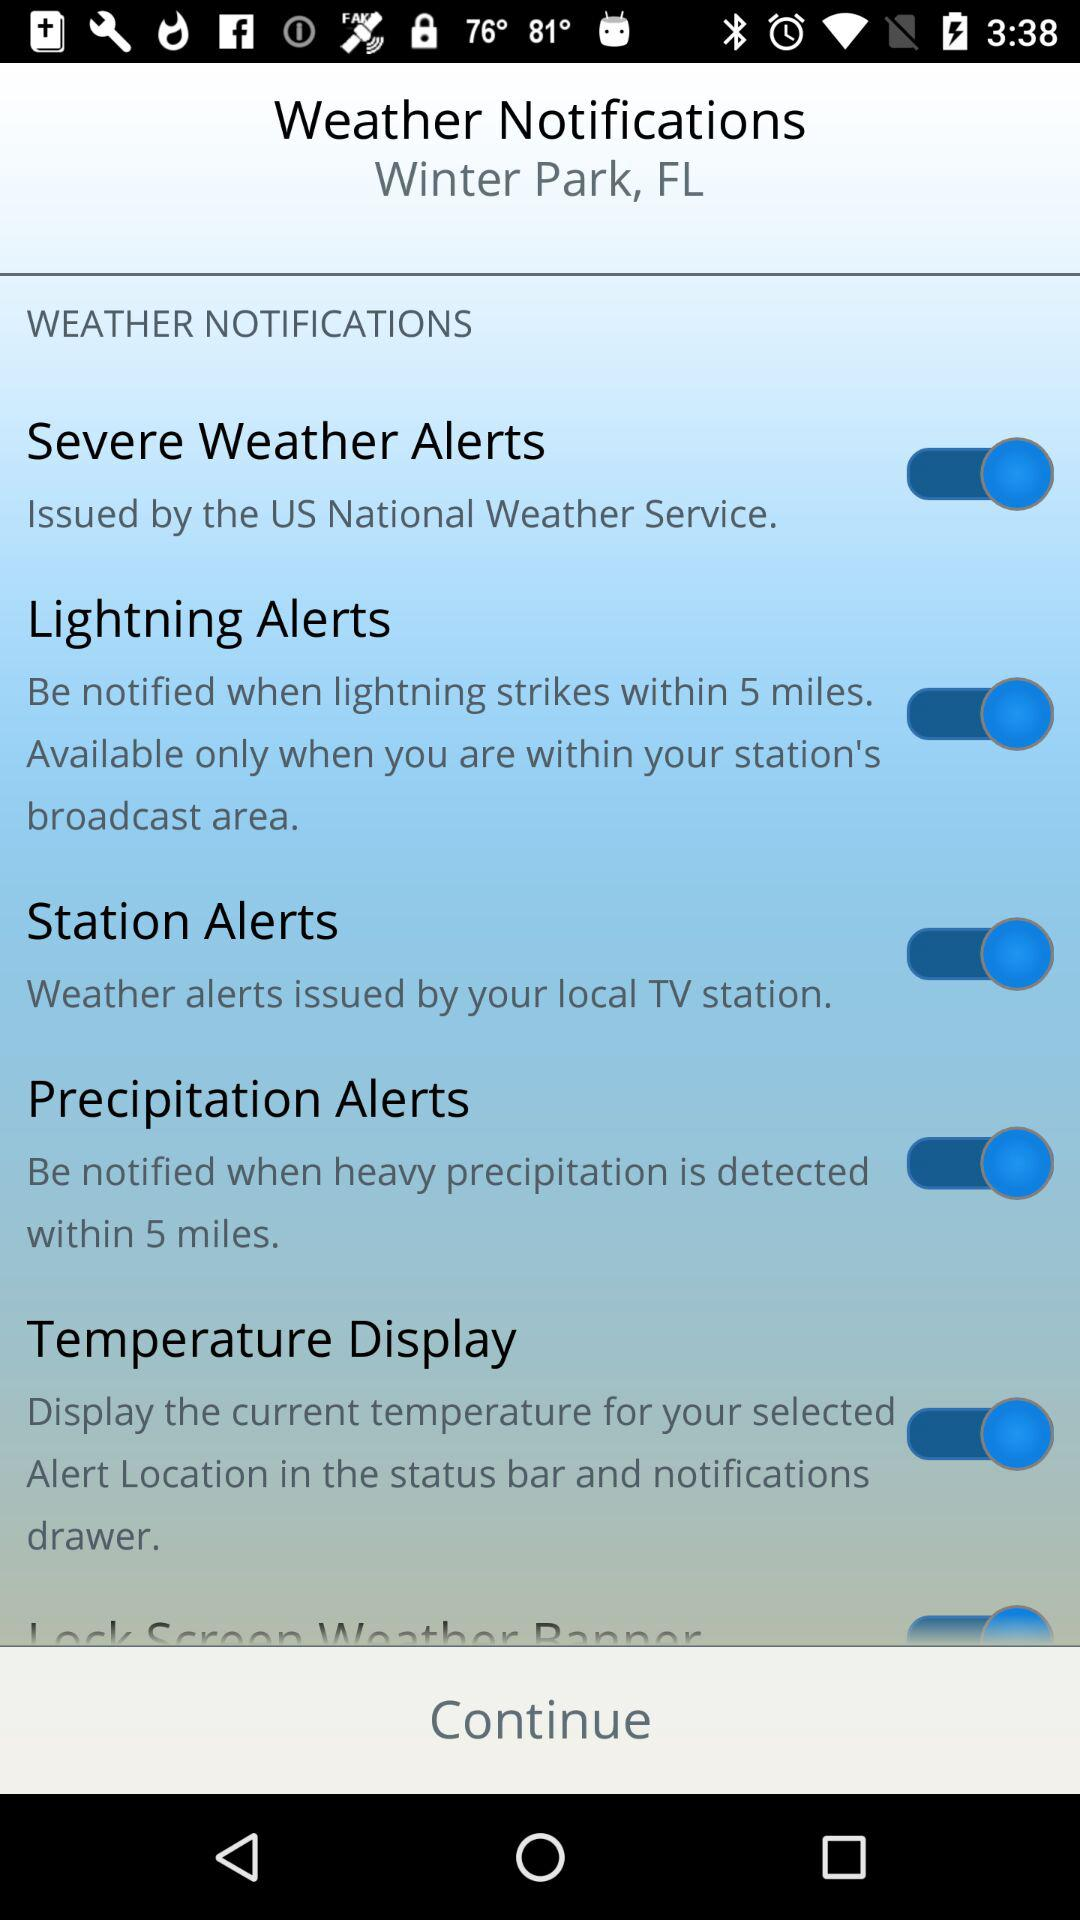What is the status of "Severe Weather Alerts" setting? The status is "on". 